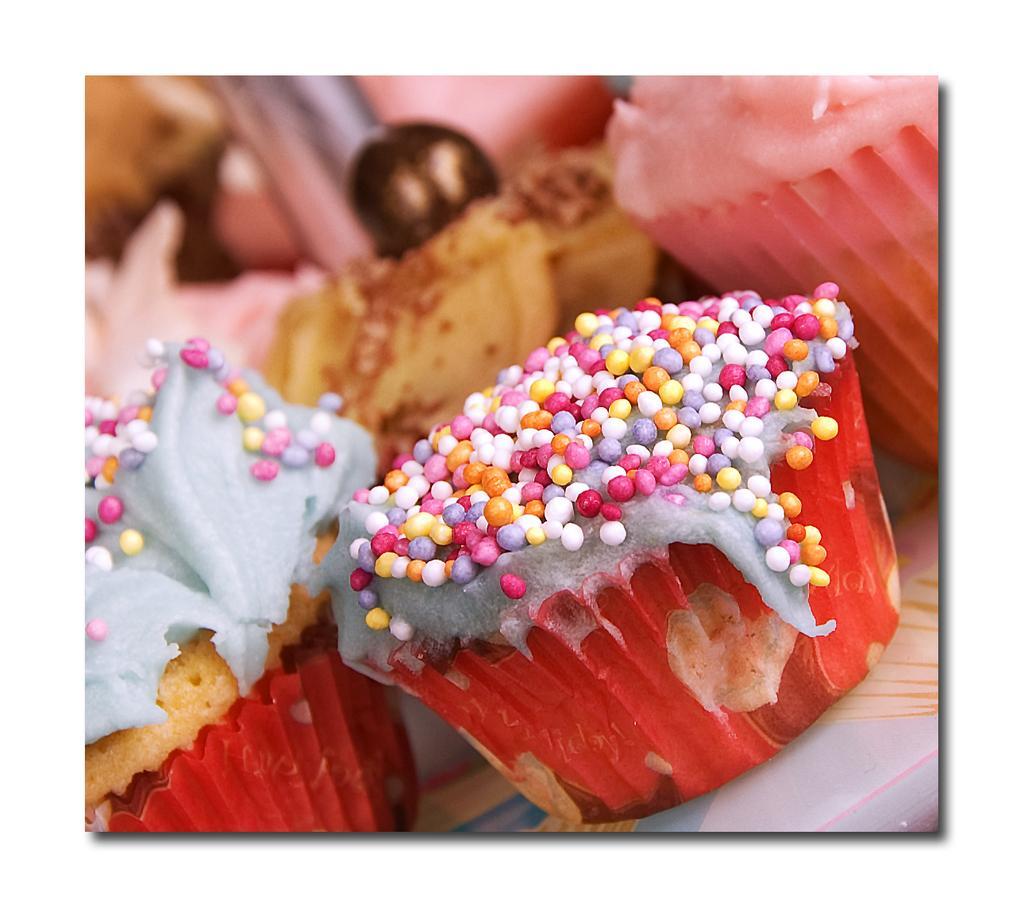Please provide a concise description of this image. In this image I can see there are few cupcakes placed on the table and there are few sprinkles on it. 